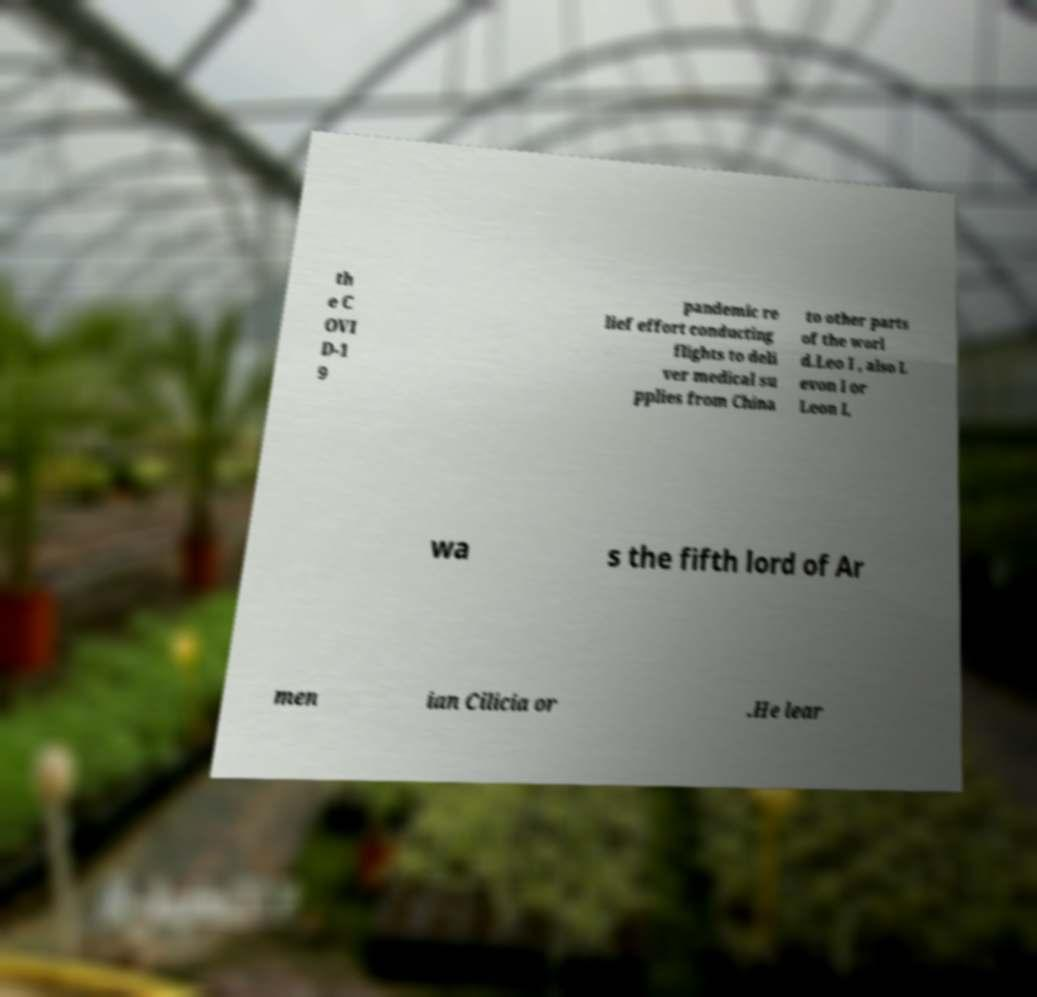Please read and relay the text visible in this image. What does it say? th e C OVI D-1 9 pandemic re lief effort conducting flights to deli ver medical su pplies from China to other parts of the worl d.Leo I , also L evon I or Leon I, wa s the fifth lord of Ar men ian Cilicia or .He lear 